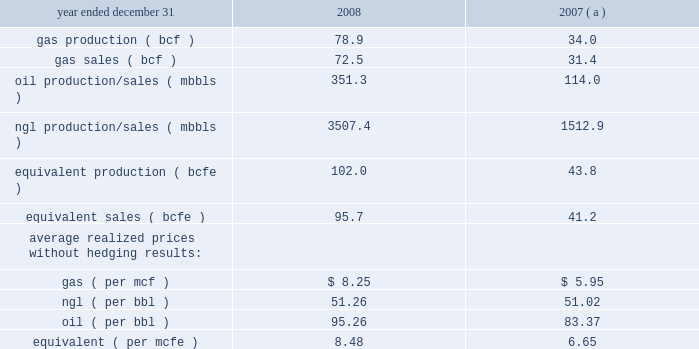Item 7 .
Management 2019s discussion and analysis of financial condition and results of operations results of operations 2013 highmount 2013 ( continued ) highmount 2019s revenues , profitability and future growth depend substantially on natural gas and ngl prices and highmount 2019s ability to increase its natural gas and ngl production .
In recent years , there has been significant price volatility in natural gas and ngl prices due to a variety of factors highmount cannot control or predict .
These factors , which include weather conditions , political and economic events , and competition from other energy sources , impact supply and demand for natural gas , which determines the pricing .
In recent months , natural gas prices decreased significantly due largely to increased onshore natural gas production , plentiful levels of working gas in storage and reduced commercial demand .
The increase in the onshore natural gas production was due largely to increased production from 201cunconventional 201d sources of natural gas such as shale gas , coalbed methane , tight sandstones and methane hydrates , made possible in recent years by modern technology in creating extensive artificial fractures around well bores and advances in horizontal drilling technology .
Other key factors contributing to the softness of natural gas prices likely included a lower level of industrial demand for natural gas , as a result of the ongoing economic downturn , and relatively low crude oil prices .
Due to industry conditions , in february of 2009 highmount elected to terminate contracts for five drilling rigs at its permian basin property in the sonora , texas area .
The estimated fee payable to the rig contractor for exercising this early termination right will be approximately $ 23 million .
In light of these developments , highmount will reduce 2009 production volumes through decreased drilling activity .
In addition , the price highmount realizes for its gas production is affected by highmount 2019s hedging activities as well as locational differences in market prices .
Highmount 2019s decision to increase its natural gas production is dependent upon highmount 2019s ability to realize attractive returns on its capital investment program .
Returns are affected by commodity prices , capital and operating costs .
Highmount 2019s operating income , which represents revenues less operating expenses , is primarily affected by revenue factors , but is also a function of varying levels of production expenses , production and ad valorem taxes , as well as depreciation , depletion and amortization ( 201cdd&a 201d ) expenses .
Highmount 2019s production expenses represent all costs incurred to operate and maintain wells and related equipment and facilities .
The principal components of highmount 2019s production expenses are , among other things , direct and indirect costs of labor and benefits , repairs and maintenance , materials , supplies and fuel .
In general , during 2008 highmount 2019s labor costs increased primarily due to higher salary levels and continued upward pressure on salaries and wages as a result of the increased competition for skilled workers .
In response to these market conditions , in 2008 highmount implemented retention programs , including increases in compensation .
Production expenses during 2008 were also affected by increases in the cost of fuel , materials and supplies .
The higher cost environment discussed above continued during all of 2008 .
During the fourth quarter of 2008 the price of natural gas declined significantly while operating expenses remained high .
This environment of low commodity prices and high operating expenses continued until december of 2008 when highmount began to see evidence of decreasing operating expenses and drilling costs .
Highmount 2019s production and ad valorem taxes increase primarily when prices of natural gas and ngls increase , but they are also affected by changes in production , as well as appreciated property values .
Highmount calculates depletion using the units-of-production method , which depletes the capitalized costs and future development costs associated with evaluated properties based on the ratio of production volumes for the current period to total remaining reserve volumes for the evaluated properties .
Highmount 2019s depletion expense is affected by its capital spending program and projected future development costs , as well as reserve changes resulting from drilling programs , well performance , and revisions due to changing commodity prices .
Presented below are production and sales statistics related to highmount 2019s operations: .

What is the 2008 rate of increase in oil production/sales? 
Computations: (351.3 / 114.0)
Answer: 3.08158. 